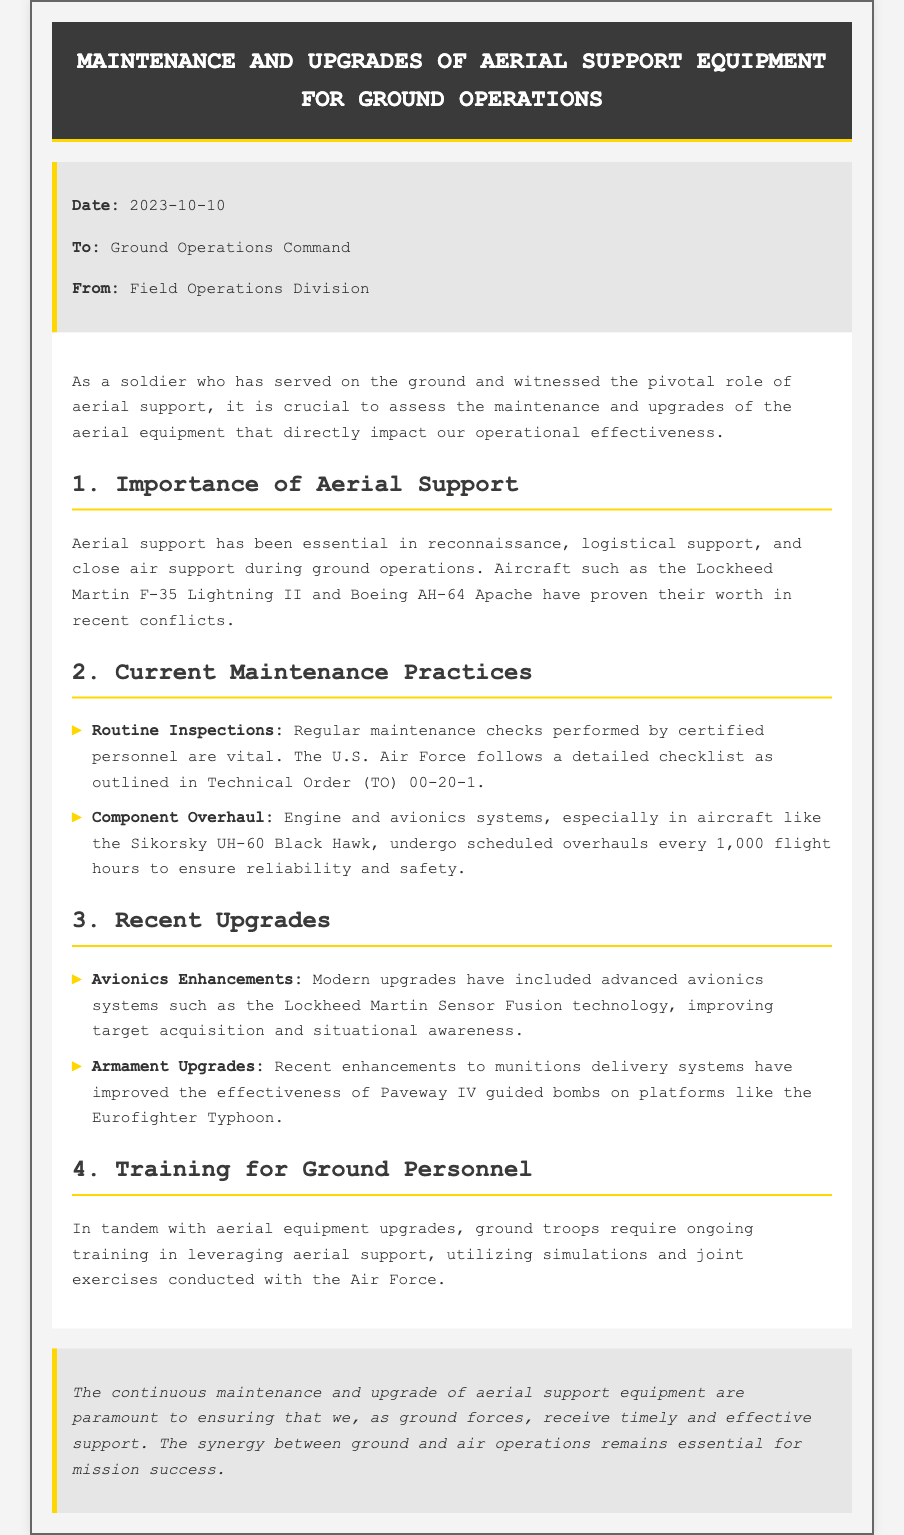What is the date of the memo? The date of the memo is mentioned in the memo details section.
Answer: 2023-10-10 Who is the memo addressed to? The recipient of the memo is specified in the detail section as Ground Operations Command.
Answer: Ground Operations Command What is the title of the memo? The title is prominently shown at the top of the document.
Answer: Maintenance and Upgrades of Aerial Support Equipment for Ground Operations What aircraft is mentioned for its avionics enhancements? The memo lists an aircraft that has received avionics enhancements in the recent upgrades section.
Answer: Lockheed Martin F-35 Lightning II How often does the Sikorsky UH-60 Black Hawk undergo component overhauls? The frequency of overhauls for the Sikorsky UH-60 Black Hawk is stated in the current maintenance practices section.
Answer: Every 1,000 flight hours What technology has been included in avionics upgrades? The specific technology that has been upgraded is mentioned in the recent upgrades section of the memo.
Answer: Lockheed Martin Sensor Fusion technology What is emphasized as essential for mission success? The relationship discussed in the conclusion highlights what is vital for effective operations.
Answer: Synergy between ground and air operations What support do ground troops require according to the memo? The type of support needed for ground personnel is described in the training for ground personnel section.
Answer: Ongoing training 